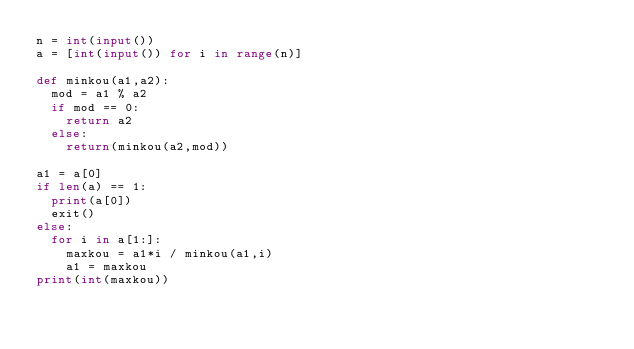Convert code to text. <code><loc_0><loc_0><loc_500><loc_500><_Python_>n = int(input())
a = [int(input()) for i in range(n)]

def minkou(a1,a2):
  mod = a1 % a2
  if mod == 0:
    return a2
  else:
    return(minkou(a2,mod))

a1 = a[0]
if len(a) == 1:
  print(a[0])
  exit()
else:
  for i in a[1:]:
    maxkou = a1*i / minkou(a1,i)
    a1 = maxkou
print(int(maxkou))</code> 